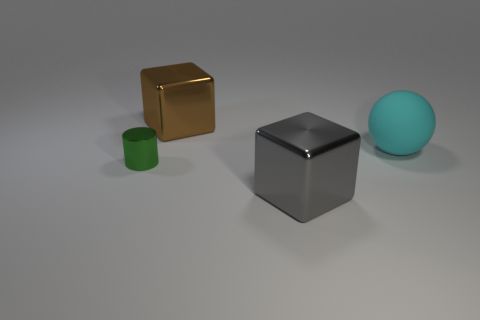Add 1 brown metal things. How many objects exist? 5 Subtract all cylinders. How many objects are left? 3 Add 3 large cyan blocks. How many large cyan blocks exist? 3 Subtract 0 blue cylinders. How many objects are left? 4 Subtract all spheres. Subtract all small green spheres. How many objects are left? 3 Add 4 big spheres. How many big spheres are left? 5 